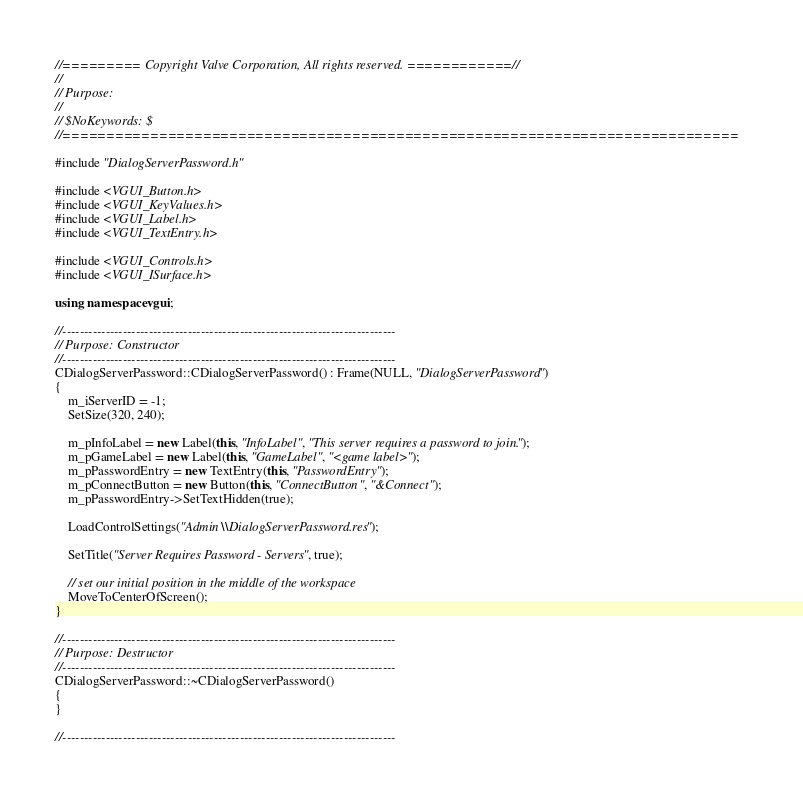Convert code to text. <code><loc_0><loc_0><loc_500><loc_500><_C++_>//========= Copyright Valve Corporation, All rights reserved. ============//
//
// Purpose: 
//
// $NoKeywords: $
//=============================================================================

#include "DialogServerPassword.h"

#include <VGUI_Button.h>
#include <VGUI_KeyValues.h>
#include <VGUI_Label.h>
#include <VGUI_TextEntry.h>

#include <VGUI_Controls.h>
#include <VGUI_ISurface.h>

using namespace vgui;

//-----------------------------------------------------------------------------
// Purpose: Constructor
//-----------------------------------------------------------------------------
CDialogServerPassword::CDialogServerPassword() : Frame(NULL, "DialogServerPassword")
{
	m_iServerID = -1;
	SetSize(320, 240);

	m_pInfoLabel = new Label(this, "InfoLabel", "This server requires a password to join.");
	m_pGameLabel = new Label(this, "GameLabel", "<game label>");
	m_pPasswordEntry = new TextEntry(this, "PasswordEntry");
	m_pConnectButton = new Button(this, "ConnectButton", "&Connect");
	m_pPasswordEntry->SetTextHidden(true);

	LoadControlSettings("Admin\\DialogServerPassword.res");

	SetTitle("Server Requires Password - Servers", true);

	// set our initial position in the middle of the workspace
	MoveToCenterOfScreen();
}

//-----------------------------------------------------------------------------
// Purpose: Destructor
//-----------------------------------------------------------------------------
CDialogServerPassword::~CDialogServerPassword()
{
}

//-----------------------------------------------------------------------------</code> 